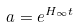<formula> <loc_0><loc_0><loc_500><loc_500>a = e ^ { H _ { \infty } t }</formula> 